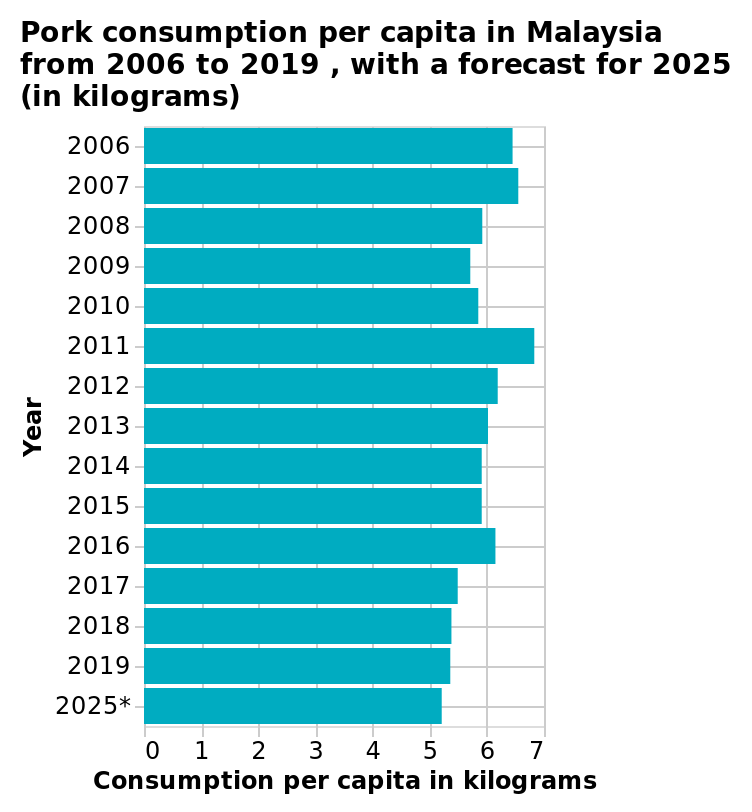<image>
please describe the details of the chart Here a is a bar graph named Pork consumption per capita in Malaysia from 2006 to 2019 , with a forecast for 2025 (in kilograms). The x-axis plots Consumption per capita in kilograms while the y-axis measures Year. What does the data show about the consumption of pork over the years?  The data shows that the consumption of pork has been fairly stable over the years. What is the forecasted year mentioned in the figure? The forecasted year mentioned in the figure is 2025. What is the title of the bar graph? The title of the bar graph is "Pork consumption per capita in Malaysia from 2006 to 2019, with a forecast for 2025". What is plotted on the x-axis of the bar graph? The x-axis of the bar graph plots "Consumption per capita in kilograms". What is the trend in pork consumption according to the data?  The trend in pork consumption is beginning to decline. What is measured on the y-axis of the bar graph? The y-axis of the bar graph measures "Year". 